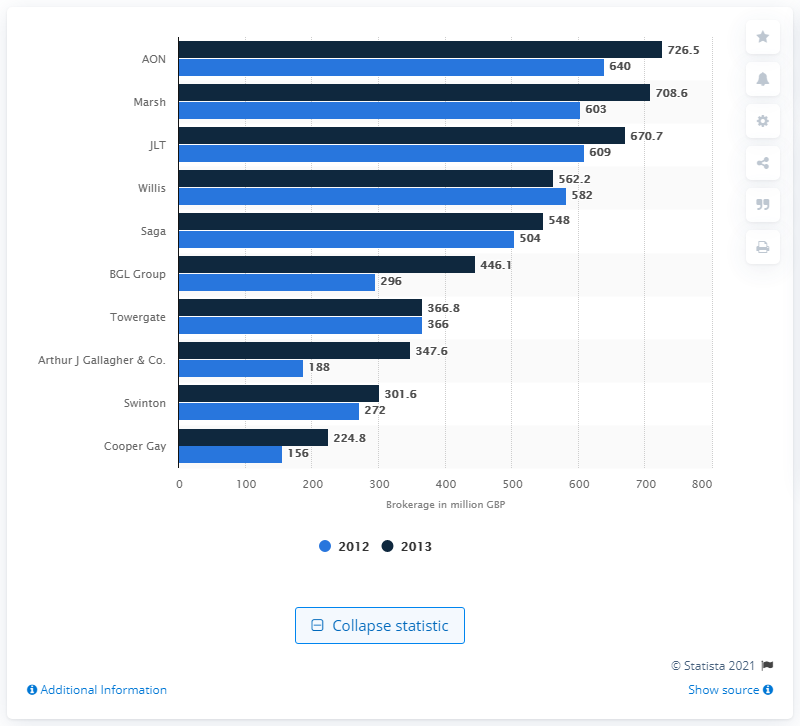Indicate a few pertinent items in this graphic. In 2012, the brokerage of AON was 640. AON earned a total of 726.5 GBP in 2013. 